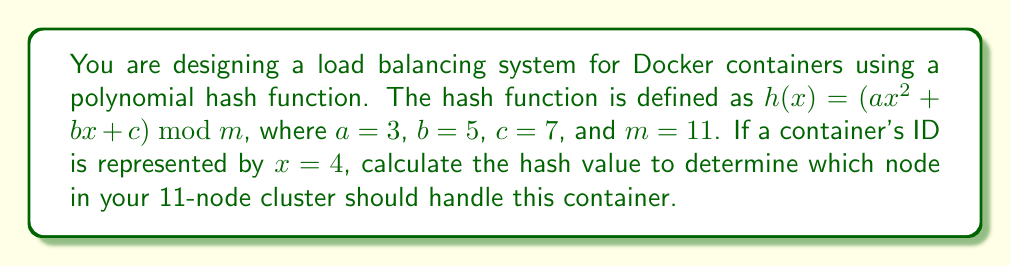What is the answer to this math problem? To solve this problem, we'll follow these steps:

1. Substitute the given values into the polynomial hash function:
   $h(x) = (3x^2 + 5x + 7) \bmod 11$, where $x=4$

2. Calculate the value of $3x^2$:
   $3 \cdot 4^2 = 3 \cdot 16 = 48$

3. Calculate the value of $5x$:
   $5 \cdot 4 = 20$

4. Sum up all terms:
   $48 + 20 + 7 = 75$

5. Apply the modulo operation:
   $75 \bmod 11 = 9$

The hash value is 9, which means the container should be assigned to node 9 in the 11-node cluster (assuming nodes are numbered from 0 to 10).
Answer: 9 